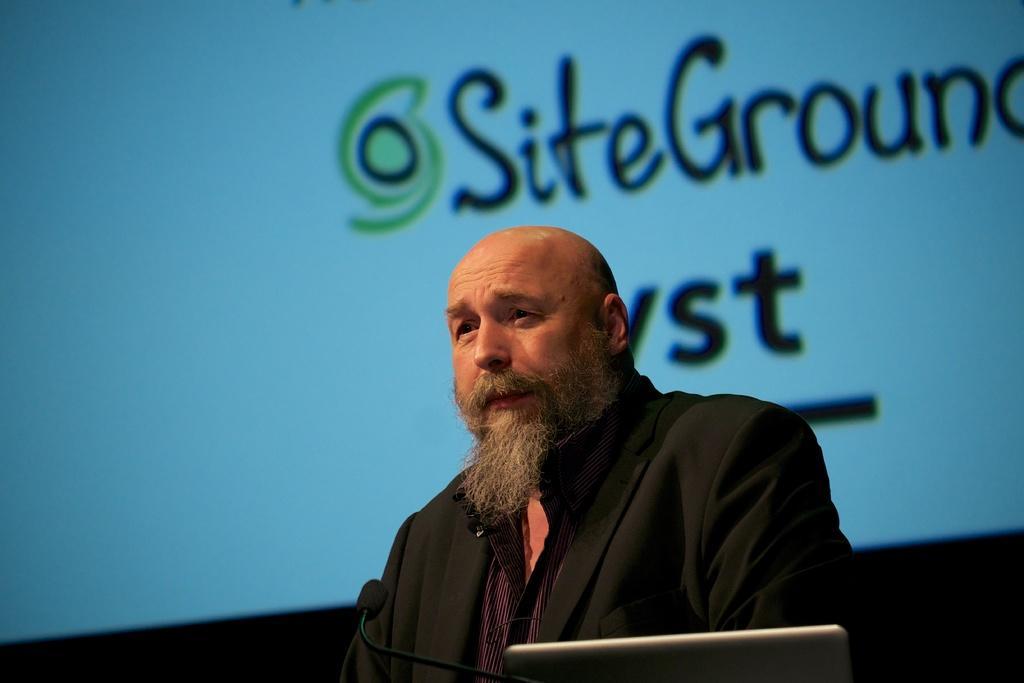How would you summarize this image in a sentence or two? In this picture there is a man with black suit and there is a microphone and there is a laptop. At the back there is text on the screen. 